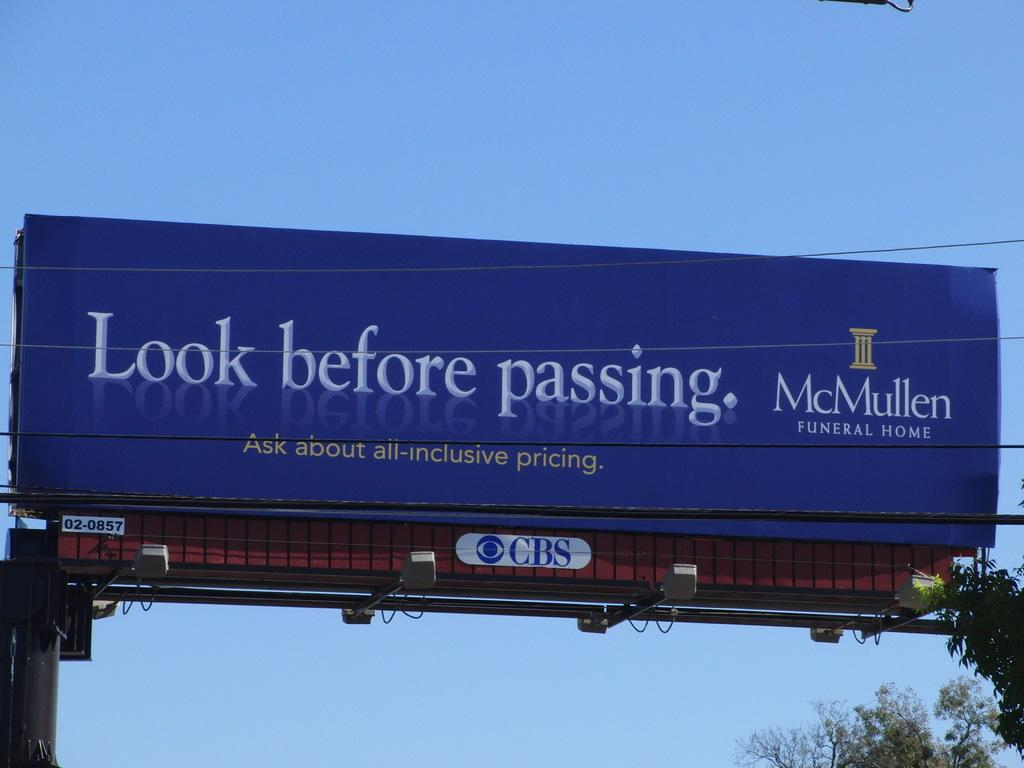<image>
Describe the image concisely. A catchy ad for a funeral home is on a billboard that talks about looking to them before passing. 